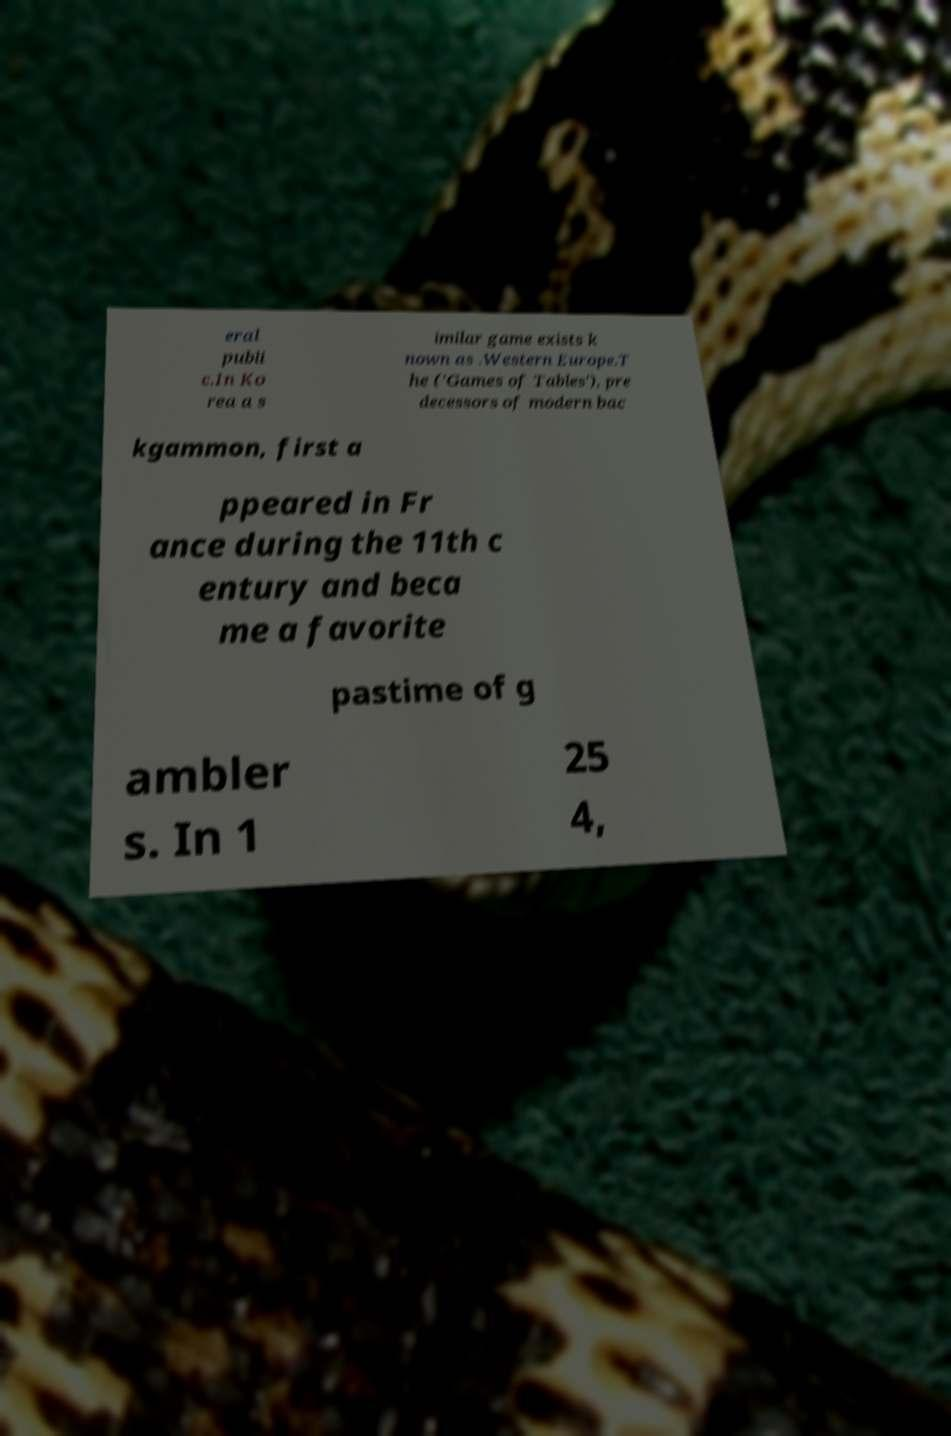Can you read and provide the text displayed in the image?This photo seems to have some interesting text. Can you extract and type it out for me? eral publi c.In Ko rea a s imilar game exists k nown as .Western Europe.T he ('Games of Tables'), pre decessors of modern bac kgammon, first a ppeared in Fr ance during the 11th c entury and beca me a favorite pastime of g ambler s. In 1 25 4, 